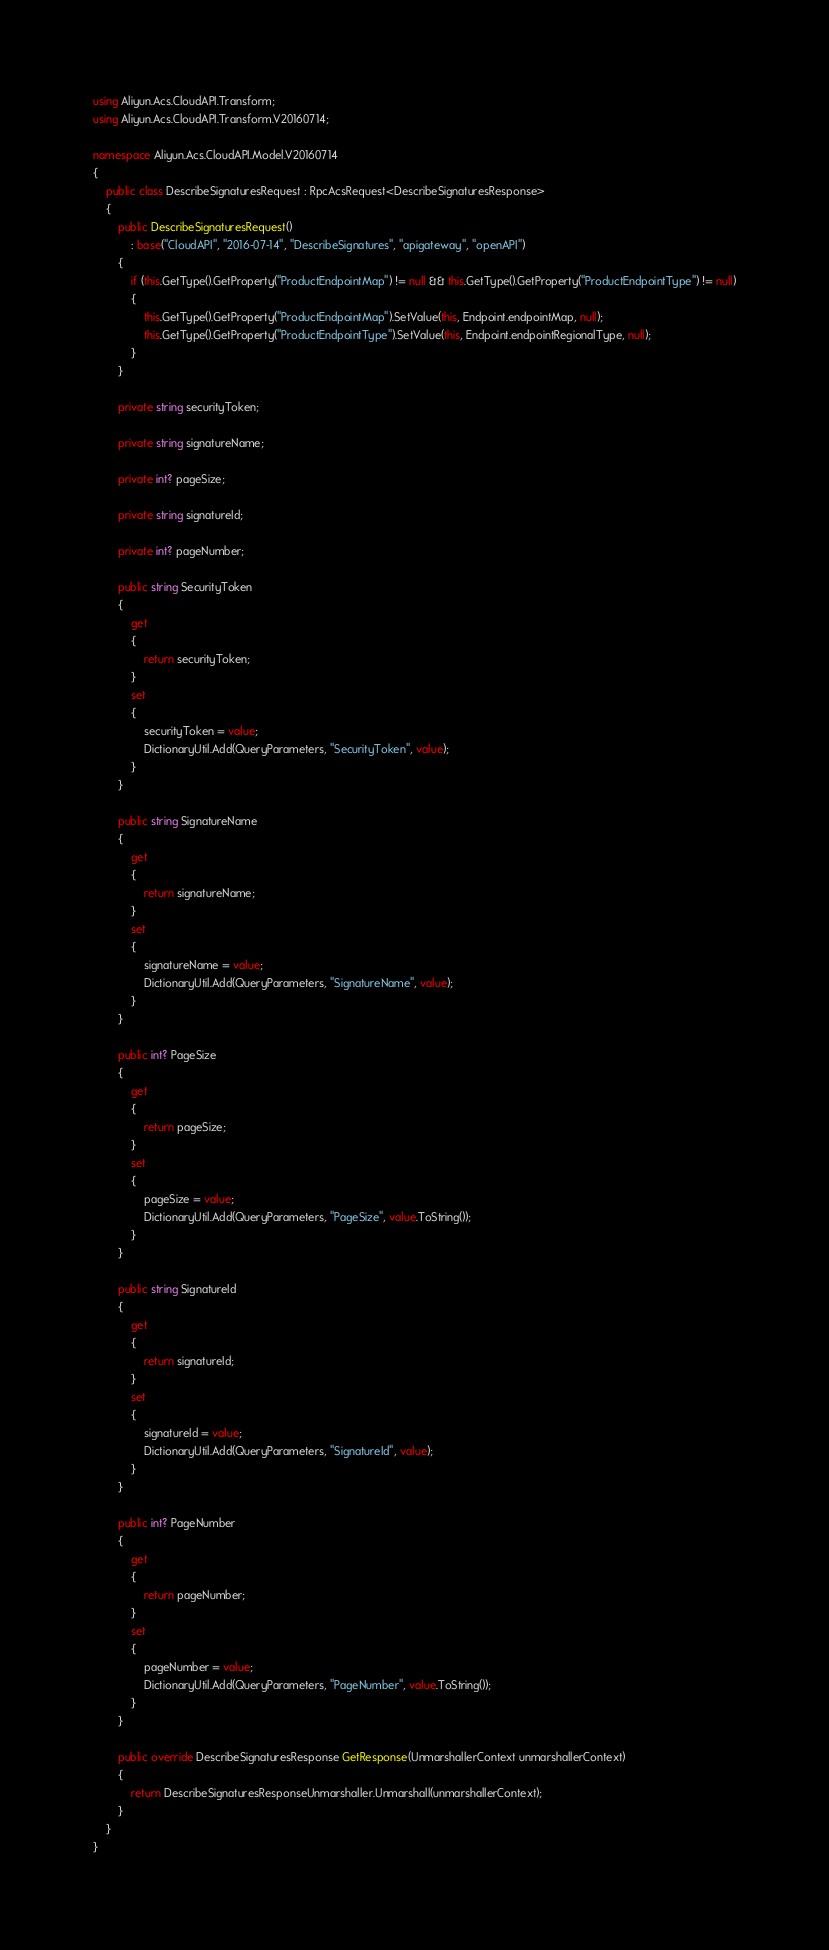Convert code to text. <code><loc_0><loc_0><loc_500><loc_500><_C#_>using Aliyun.Acs.CloudAPI.Transform;
using Aliyun.Acs.CloudAPI.Transform.V20160714;

namespace Aliyun.Acs.CloudAPI.Model.V20160714
{
    public class DescribeSignaturesRequest : RpcAcsRequest<DescribeSignaturesResponse>
    {
        public DescribeSignaturesRequest()
            : base("CloudAPI", "2016-07-14", "DescribeSignatures", "apigateway", "openAPI")
        {
            if (this.GetType().GetProperty("ProductEndpointMap") != null && this.GetType().GetProperty("ProductEndpointType") != null)
            {
                this.GetType().GetProperty("ProductEndpointMap").SetValue(this, Endpoint.endpointMap, null);
                this.GetType().GetProperty("ProductEndpointType").SetValue(this, Endpoint.endpointRegionalType, null);
            }
        }

		private string securityToken;

		private string signatureName;

		private int? pageSize;

		private string signatureId;

		private int? pageNumber;

		public string SecurityToken
		{
			get
			{
				return securityToken;
			}
			set	
			{
				securityToken = value;
				DictionaryUtil.Add(QueryParameters, "SecurityToken", value);
			}
		}

		public string SignatureName
		{
			get
			{
				return signatureName;
			}
			set	
			{
				signatureName = value;
				DictionaryUtil.Add(QueryParameters, "SignatureName", value);
			}
		}

		public int? PageSize
		{
			get
			{
				return pageSize;
			}
			set	
			{
				pageSize = value;
				DictionaryUtil.Add(QueryParameters, "PageSize", value.ToString());
			}
		}

		public string SignatureId
		{
			get
			{
				return signatureId;
			}
			set	
			{
				signatureId = value;
				DictionaryUtil.Add(QueryParameters, "SignatureId", value);
			}
		}

		public int? PageNumber
		{
			get
			{
				return pageNumber;
			}
			set	
			{
				pageNumber = value;
				DictionaryUtil.Add(QueryParameters, "PageNumber", value.ToString());
			}
		}

        public override DescribeSignaturesResponse GetResponse(UnmarshallerContext unmarshallerContext)
        {
            return DescribeSignaturesResponseUnmarshaller.Unmarshall(unmarshallerContext);
        }
    }
}
</code> 